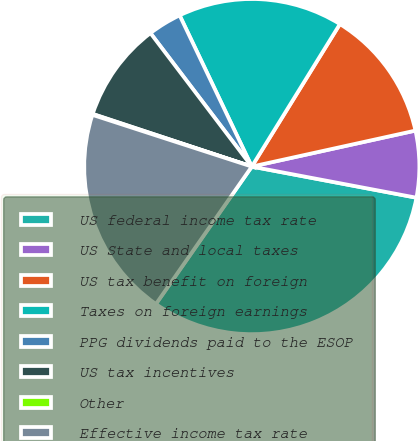Convert chart to OTSL. <chart><loc_0><loc_0><loc_500><loc_500><pie_chart><fcel>US federal income tax rate<fcel>US State and local taxes<fcel>US tax benefit on foreign<fcel>Taxes on foreign earnings<fcel>PPG dividends paid to the ESOP<fcel>US tax incentives<fcel>Other<fcel>Effective income tax rate<nl><fcel>31.72%<fcel>6.42%<fcel>12.74%<fcel>15.9%<fcel>3.25%<fcel>9.58%<fcel>0.09%<fcel>20.3%<nl></chart> 